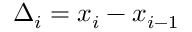Convert formula to latex. <formula><loc_0><loc_0><loc_500><loc_500>\Delta _ { i } = x _ { i } - x _ { i - 1 }</formula> 